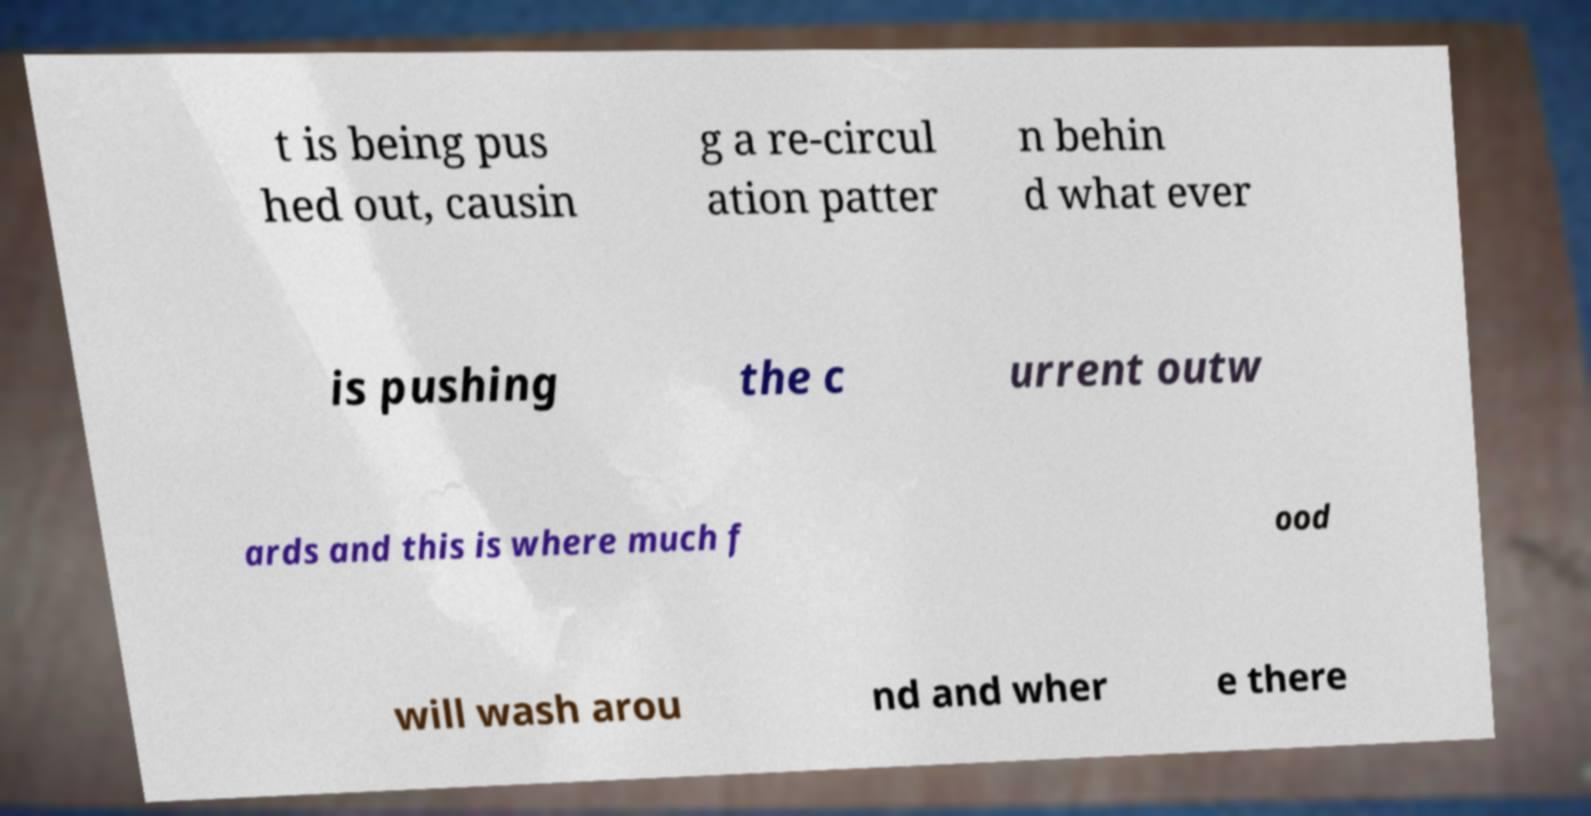For documentation purposes, I need the text within this image transcribed. Could you provide that? t is being pus hed out, causin g a re-circul ation patter n behin d what ever is pushing the c urrent outw ards and this is where much f ood will wash arou nd and wher e there 